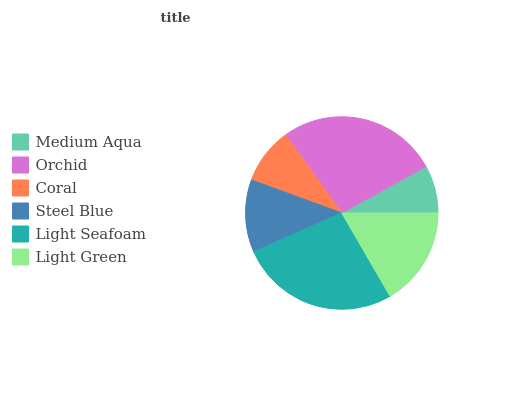Is Medium Aqua the minimum?
Answer yes or no. Yes. Is Orchid the maximum?
Answer yes or no. Yes. Is Coral the minimum?
Answer yes or no. No. Is Coral the maximum?
Answer yes or no. No. Is Orchid greater than Coral?
Answer yes or no. Yes. Is Coral less than Orchid?
Answer yes or no. Yes. Is Coral greater than Orchid?
Answer yes or no. No. Is Orchid less than Coral?
Answer yes or no. No. Is Light Green the high median?
Answer yes or no. Yes. Is Steel Blue the low median?
Answer yes or no. Yes. Is Light Seafoam the high median?
Answer yes or no. No. Is Light Seafoam the low median?
Answer yes or no. No. 